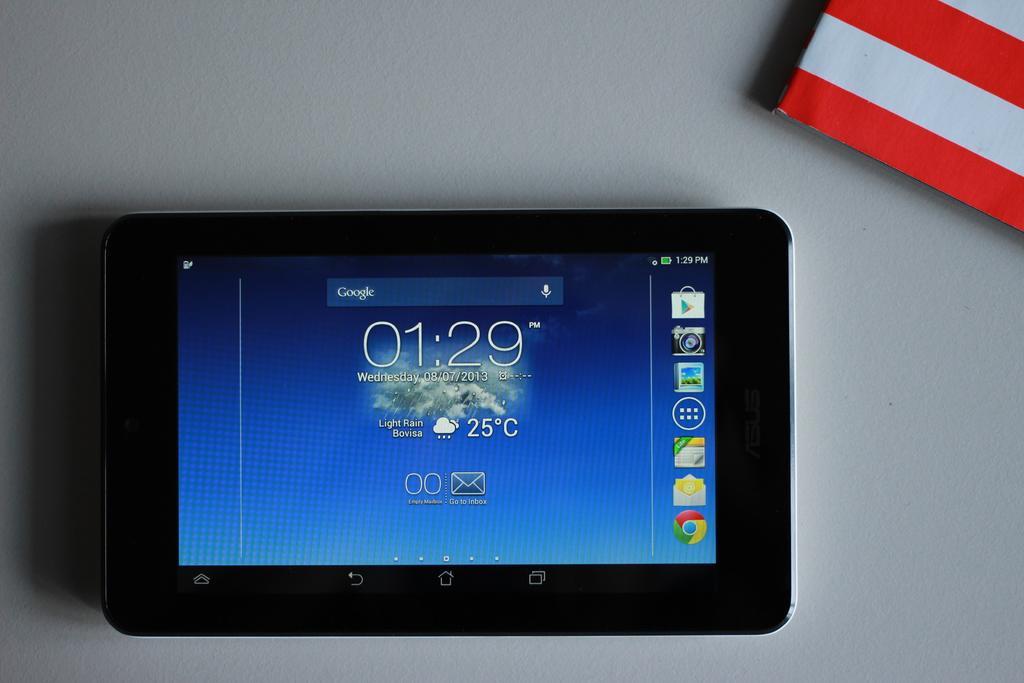How would you summarize this image in a sentence or two? In this image I can see the iPad which is in black color. To the side there is a red and white color object. These are on the white color surface. 